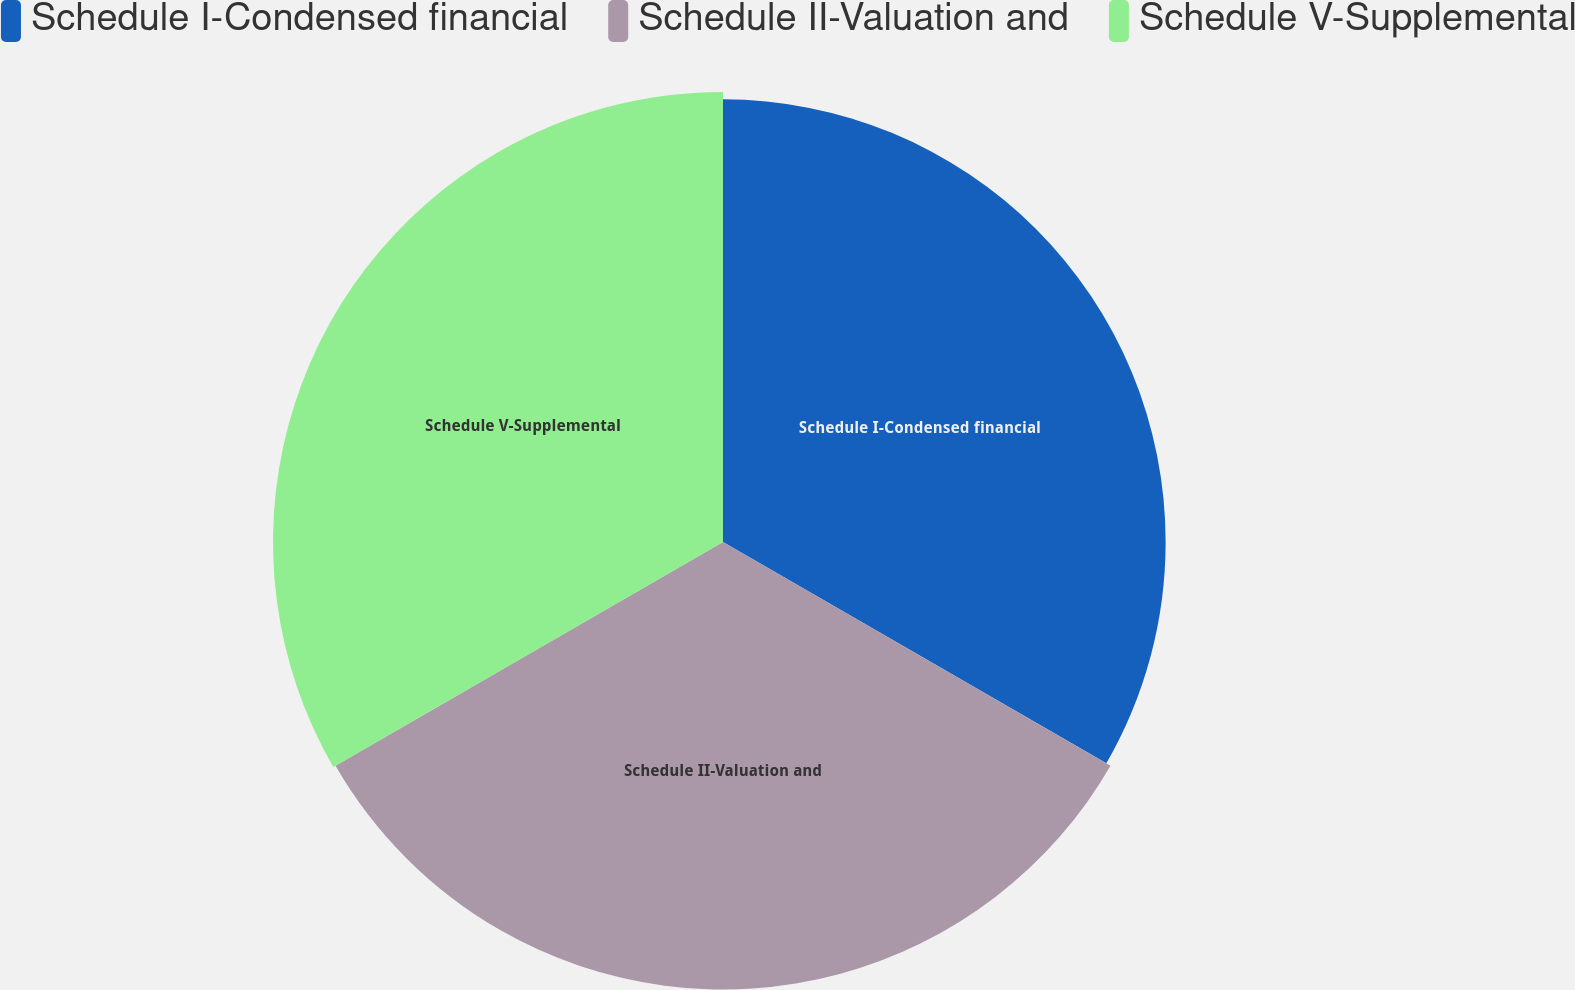Convert chart. <chart><loc_0><loc_0><loc_500><loc_500><pie_chart><fcel>Schedule I-Condensed financial<fcel>Schedule II-Valuation and<fcel>Schedule V-Supplemental<nl><fcel>33.03%<fcel>33.39%<fcel>33.58%<nl></chart> 